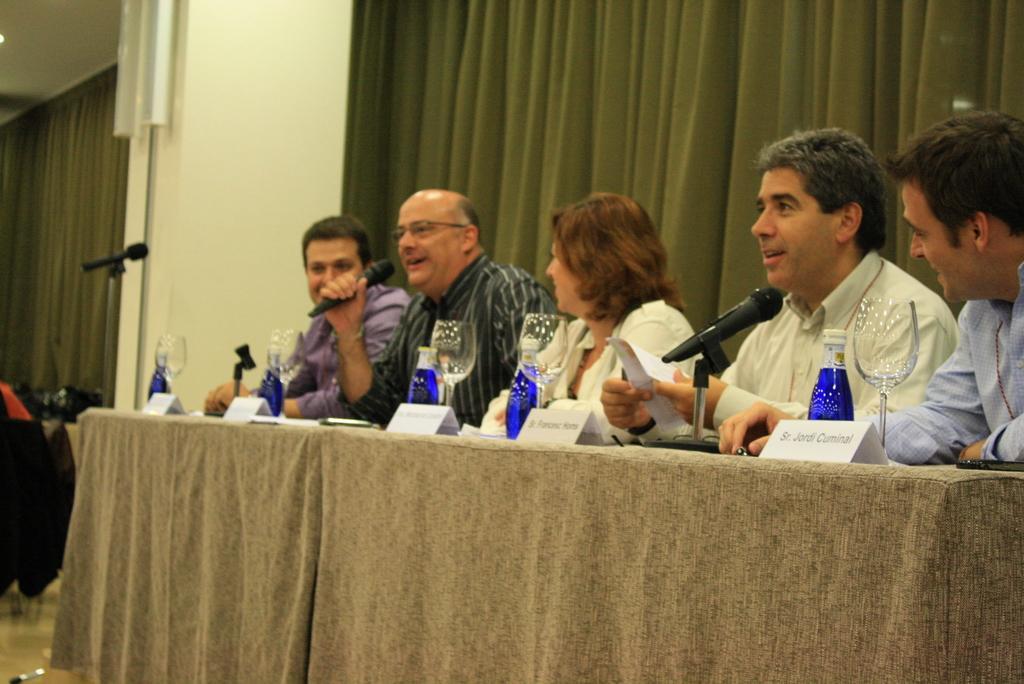Please provide a concise description of this image. In the image in the center we can see few people were sitting and smiling. And we can see two persons were holding paper and microphone. In front of them,there is a table. On the table,we can see one cloth,glasses,bottles,microphones and few other objects. In the background there is a wall,chairs,curtains etc. 